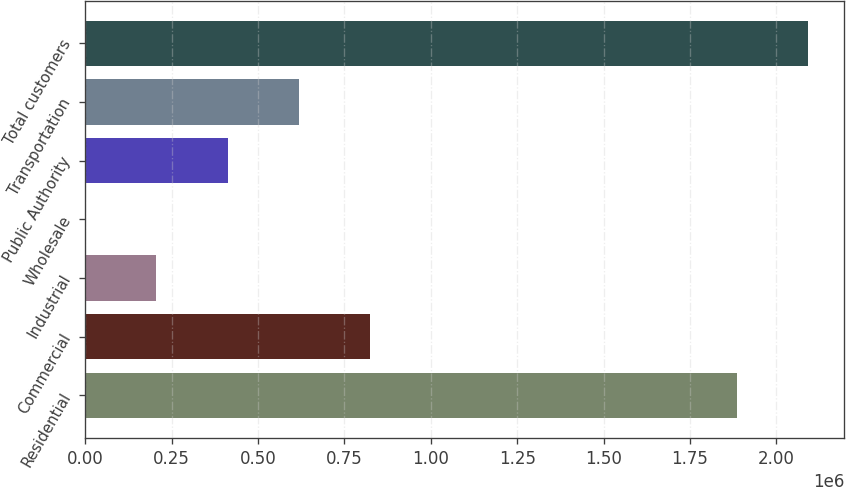<chart> <loc_0><loc_0><loc_500><loc_500><bar_chart><fcel>Residential<fcel>Commercial<fcel>Industrial<fcel>Wholesale<fcel>Public Authority<fcel>Transportation<fcel>Total customers<nl><fcel>1.88612e+06<fcel>824278<fcel>206090<fcel>28<fcel>412153<fcel>618216<fcel>2.09218e+06<nl></chart> 